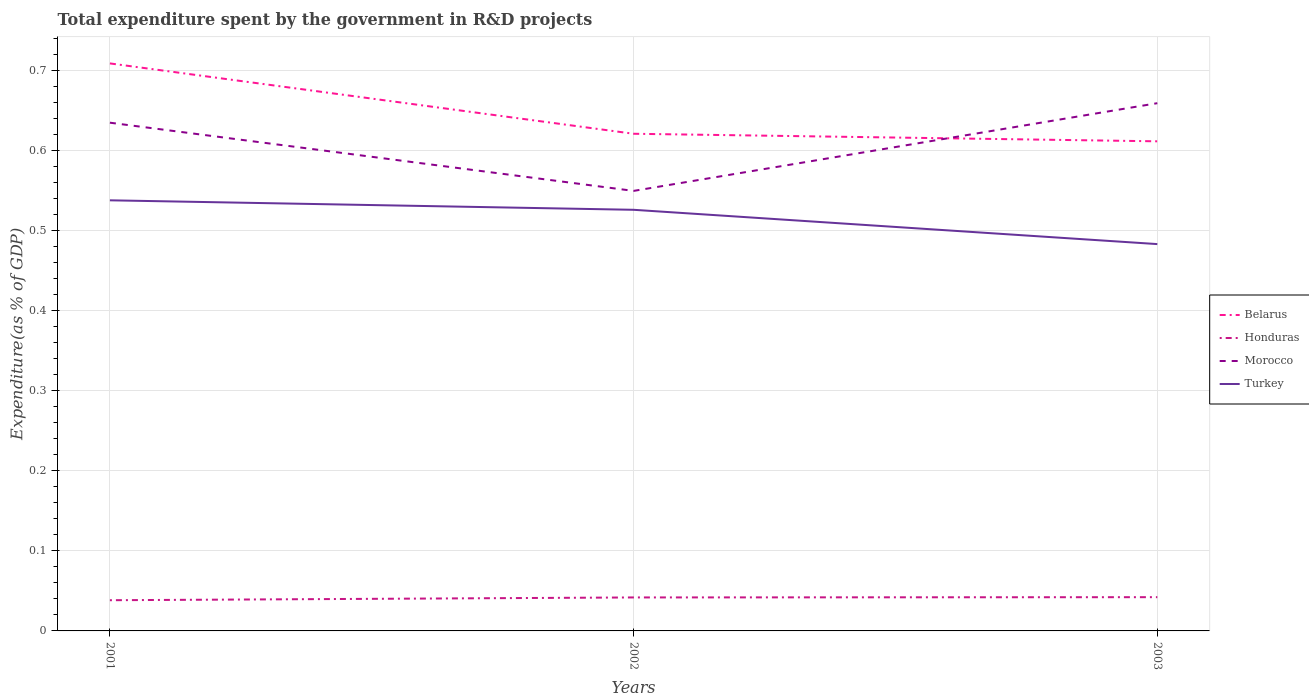How many different coloured lines are there?
Keep it short and to the point. 4. Across all years, what is the maximum total expenditure spent by the government in R&D projects in Morocco?
Keep it short and to the point. 0.55. In which year was the total expenditure spent by the government in R&D projects in Turkey maximum?
Make the answer very short. 2003. What is the total total expenditure spent by the government in R&D projects in Morocco in the graph?
Ensure brevity in your answer.  -0.02. What is the difference between the highest and the second highest total expenditure spent by the government in R&D projects in Honduras?
Your response must be concise. 0. Is the total expenditure spent by the government in R&D projects in Morocco strictly greater than the total expenditure spent by the government in R&D projects in Honduras over the years?
Provide a succinct answer. No. How many lines are there?
Make the answer very short. 4. Where does the legend appear in the graph?
Give a very brief answer. Center right. What is the title of the graph?
Make the answer very short. Total expenditure spent by the government in R&D projects. What is the label or title of the Y-axis?
Provide a succinct answer. Expenditure(as % of GDP). What is the Expenditure(as % of GDP) in Belarus in 2001?
Your response must be concise. 0.71. What is the Expenditure(as % of GDP) of Honduras in 2001?
Give a very brief answer. 0.04. What is the Expenditure(as % of GDP) of Morocco in 2001?
Offer a very short reply. 0.63. What is the Expenditure(as % of GDP) in Turkey in 2001?
Your answer should be compact. 0.54. What is the Expenditure(as % of GDP) of Belarus in 2002?
Give a very brief answer. 0.62. What is the Expenditure(as % of GDP) in Honduras in 2002?
Provide a short and direct response. 0.04. What is the Expenditure(as % of GDP) in Morocco in 2002?
Give a very brief answer. 0.55. What is the Expenditure(as % of GDP) in Turkey in 2002?
Your answer should be very brief. 0.53. What is the Expenditure(as % of GDP) of Belarus in 2003?
Offer a very short reply. 0.61. What is the Expenditure(as % of GDP) in Honduras in 2003?
Make the answer very short. 0.04. What is the Expenditure(as % of GDP) in Morocco in 2003?
Make the answer very short. 0.66. What is the Expenditure(as % of GDP) of Turkey in 2003?
Provide a succinct answer. 0.48. Across all years, what is the maximum Expenditure(as % of GDP) in Belarus?
Make the answer very short. 0.71. Across all years, what is the maximum Expenditure(as % of GDP) in Honduras?
Give a very brief answer. 0.04. Across all years, what is the maximum Expenditure(as % of GDP) of Morocco?
Provide a short and direct response. 0.66. Across all years, what is the maximum Expenditure(as % of GDP) of Turkey?
Offer a very short reply. 0.54. Across all years, what is the minimum Expenditure(as % of GDP) in Belarus?
Your answer should be compact. 0.61. Across all years, what is the minimum Expenditure(as % of GDP) of Honduras?
Offer a very short reply. 0.04. Across all years, what is the minimum Expenditure(as % of GDP) in Morocco?
Offer a terse response. 0.55. Across all years, what is the minimum Expenditure(as % of GDP) in Turkey?
Give a very brief answer. 0.48. What is the total Expenditure(as % of GDP) in Belarus in the graph?
Provide a succinct answer. 1.94. What is the total Expenditure(as % of GDP) in Honduras in the graph?
Your answer should be very brief. 0.12. What is the total Expenditure(as % of GDP) of Morocco in the graph?
Offer a very short reply. 1.84. What is the total Expenditure(as % of GDP) of Turkey in the graph?
Offer a very short reply. 1.55. What is the difference between the Expenditure(as % of GDP) of Belarus in 2001 and that in 2002?
Ensure brevity in your answer.  0.09. What is the difference between the Expenditure(as % of GDP) in Honduras in 2001 and that in 2002?
Your response must be concise. -0. What is the difference between the Expenditure(as % of GDP) of Morocco in 2001 and that in 2002?
Provide a short and direct response. 0.09. What is the difference between the Expenditure(as % of GDP) of Turkey in 2001 and that in 2002?
Keep it short and to the point. 0.01. What is the difference between the Expenditure(as % of GDP) in Belarus in 2001 and that in 2003?
Your answer should be very brief. 0.1. What is the difference between the Expenditure(as % of GDP) in Honduras in 2001 and that in 2003?
Your answer should be compact. -0. What is the difference between the Expenditure(as % of GDP) of Morocco in 2001 and that in 2003?
Your answer should be compact. -0.02. What is the difference between the Expenditure(as % of GDP) of Turkey in 2001 and that in 2003?
Offer a very short reply. 0.05. What is the difference between the Expenditure(as % of GDP) in Belarus in 2002 and that in 2003?
Make the answer very short. 0.01. What is the difference between the Expenditure(as % of GDP) in Honduras in 2002 and that in 2003?
Offer a terse response. -0. What is the difference between the Expenditure(as % of GDP) of Morocco in 2002 and that in 2003?
Offer a very short reply. -0.11. What is the difference between the Expenditure(as % of GDP) in Turkey in 2002 and that in 2003?
Keep it short and to the point. 0.04. What is the difference between the Expenditure(as % of GDP) in Belarus in 2001 and the Expenditure(as % of GDP) in Honduras in 2002?
Keep it short and to the point. 0.67. What is the difference between the Expenditure(as % of GDP) in Belarus in 2001 and the Expenditure(as % of GDP) in Morocco in 2002?
Your response must be concise. 0.16. What is the difference between the Expenditure(as % of GDP) of Belarus in 2001 and the Expenditure(as % of GDP) of Turkey in 2002?
Ensure brevity in your answer.  0.18. What is the difference between the Expenditure(as % of GDP) of Honduras in 2001 and the Expenditure(as % of GDP) of Morocco in 2002?
Ensure brevity in your answer.  -0.51. What is the difference between the Expenditure(as % of GDP) of Honduras in 2001 and the Expenditure(as % of GDP) of Turkey in 2002?
Your answer should be very brief. -0.49. What is the difference between the Expenditure(as % of GDP) in Morocco in 2001 and the Expenditure(as % of GDP) in Turkey in 2002?
Provide a succinct answer. 0.11. What is the difference between the Expenditure(as % of GDP) of Belarus in 2001 and the Expenditure(as % of GDP) of Honduras in 2003?
Provide a succinct answer. 0.67. What is the difference between the Expenditure(as % of GDP) of Belarus in 2001 and the Expenditure(as % of GDP) of Morocco in 2003?
Offer a very short reply. 0.05. What is the difference between the Expenditure(as % of GDP) in Belarus in 2001 and the Expenditure(as % of GDP) in Turkey in 2003?
Keep it short and to the point. 0.23. What is the difference between the Expenditure(as % of GDP) in Honduras in 2001 and the Expenditure(as % of GDP) in Morocco in 2003?
Provide a short and direct response. -0.62. What is the difference between the Expenditure(as % of GDP) of Honduras in 2001 and the Expenditure(as % of GDP) of Turkey in 2003?
Keep it short and to the point. -0.44. What is the difference between the Expenditure(as % of GDP) of Morocco in 2001 and the Expenditure(as % of GDP) of Turkey in 2003?
Your answer should be compact. 0.15. What is the difference between the Expenditure(as % of GDP) of Belarus in 2002 and the Expenditure(as % of GDP) of Honduras in 2003?
Your answer should be very brief. 0.58. What is the difference between the Expenditure(as % of GDP) of Belarus in 2002 and the Expenditure(as % of GDP) of Morocco in 2003?
Provide a short and direct response. -0.04. What is the difference between the Expenditure(as % of GDP) of Belarus in 2002 and the Expenditure(as % of GDP) of Turkey in 2003?
Your answer should be very brief. 0.14. What is the difference between the Expenditure(as % of GDP) of Honduras in 2002 and the Expenditure(as % of GDP) of Morocco in 2003?
Your answer should be compact. -0.62. What is the difference between the Expenditure(as % of GDP) in Honduras in 2002 and the Expenditure(as % of GDP) in Turkey in 2003?
Your answer should be compact. -0.44. What is the difference between the Expenditure(as % of GDP) in Morocco in 2002 and the Expenditure(as % of GDP) in Turkey in 2003?
Give a very brief answer. 0.07. What is the average Expenditure(as % of GDP) of Belarus per year?
Your answer should be very brief. 0.65. What is the average Expenditure(as % of GDP) in Honduras per year?
Your response must be concise. 0.04. What is the average Expenditure(as % of GDP) in Morocco per year?
Provide a succinct answer. 0.61. What is the average Expenditure(as % of GDP) of Turkey per year?
Offer a very short reply. 0.52. In the year 2001, what is the difference between the Expenditure(as % of GDP) of Belarus and Expenditure(as % of GDP) of Honduras?
Your answer should be very brief. 0.67. In the year 2001, what is the difference between the Expenditure(as % of GDP) of Belarus and Expenditure(as % of GDP) of Morocco?
Your answer should be compact. 0.07. In the year 2001, what is the difference between the Expenditure(as % of GDP) of Belarus and Expenditure(as % of GDP) of Turkey?
Keep it short and to the point. 0.17. In the year 2001, what is the difference between the Expenditure(as % of GDP) in Honduras and Expenditure(as % of GDP) in Morocco?
Provide a succinct answer. -0.6. In the year 2001, what is the difference between the Expenditure(as % of GDP) of Honduras and Expenditure(as % of GDP) of Turkey?
Provide a succinct answer. -0.5. In the year 2001, what is the difference between the Expenditure(as % of GDP) in Morocco and Expenditure(as % of GDP) in Turkey?
Provide a succinct answer. 0.1. In the year 2002, what is the difference between the Expenditure(as % of GDP) in Belarus and Expenditure(as % of GDP) in Honduras?
Give a very brief answer. 0.58. In the year 2002, what is the difference between the Expenditure(as % of GDP) of Belarus and Expenditure(as % of GDP) of Morocco?
Offer a terse response. 0.07. In the year 2002, what is the difference between the Expenditure(as % of GDP) in Belarus and Expenditure(as % of GDP) in Turkey?
Your answer should be compact. 0.1. In the year 2002, what is the difference between the Expenditure(as % of GDP) of Honduras and Expenditure(as % of GDP) of Morocco?
Offer a very short reply. -0.51. In the year 2002, what is the difference between the Expenditure(as % of GDP) in Honduras and Expenditure(as % of GDP) in Turkey?
Give a very brief answer. -0.48. In the year 2002, what is the difference between the Expenditure(as % of GDP) in Morocco and Expenditure(as % of GDP) in Turkey?
Keep it short and to the point. 0.02. In the year 2003, what is the difference between the Expenditure(as % of GDP) in Belarus and Expenditure(as % of GDP) in Honduras?
Make the answer very short. 0.57. In the year 2003, what is the difference between the Expenditure(as % of GDP) of Belarus and Expenditure(as % of GDP) of Morocco?
Make the answer very short. -0.05. In the year 2003, what is the difference between the Expenditure(as % of GDP) in Belarus and Expenditure(as % of GDP) in Turkey?
Your answer should be very brief. 0.13. In the year 2003, what is the difference between the Expenditure(as % of GDP) of Honduras and Expenditure(as % of GDP) of Morocco?
Your answer should be compact. -0.62. In the year 2003, what is the difference between the Expenditure(as % of GDP) in Honduras and Expenditure(as % of GDP) in Turkey?
Offer a very short reply. -0.44. In the year 2003, what is the difference between the Expenditure(as % of GDP) of Morocco and Expenditure(as % of GDP) of Turkey?
Keep it short and to the point. 0.18. What is the ratio of the Expenditure(as % of GDP) in Belarus in 2001 to that in 2002?
Your response must be concise. 1.14. What is the ratio of the Expenditure(as % of GDP) of Honduras in 2001 to that in 2002?
Give a very brief answer. 0.92. What is the ratio of the Expenditure(as % of GDP) in Morocco in 2001 to that in 2002?
Make the answer very short. 1.16. What is the ratio of the Expenditure(as % of GDP) of Turkey in 2001 to that in 2002?
Your answer should be very brief. 1.02. What is the ratio of the Expenditure(as % of GDP) in Belarus in 2001 to that in 2003?
Provide a succinct answer. 1.16. What is the ratio of the Expenditure(as % of GDP) in Honduras in 2001 to that in 2003?
Your response must be concise. 0.91. What is the ratio of the Expenditure(as % of GDP) in Turkey in 2001 to that in 2003?
Provide a succinct answer. 1.11. What is the ratio of the Expenditure(as % of GDP) of Belarus in 2002 to that in 2003?
Ensure brevity in your answer.  1.02. What is the ratio of the Expenditure(as % of GDP) of Morocco in 2002 to that in 2003?
Offer a terse response. 0.83. What is the ratio of the Expenditure(as % of GDP) of Turkey in 2002 to that in 2003?
Provide a succinct answer. 1.09. What is the difference between the highest and the second highest Expenditure(as % of GDP) in Belarus?
Your response must be concise. 0.09. What is the difference between the highest and the second highest Expenditure(as % of GDP) of Morocco?
Make the answer very short. 0.02. What is the difference between the highest and the second highest Expenditure(as % of GDP) in Turkey?
Give a very brief answer. 0.01. What is the difference between the highest and the lowest Expenditure(as % of GDP) in Belarus?
Your response must be concise. 0.1. What is the difference between the highest and the lowest Expenditure(as % of GDP) of Honduras?
Give a very brief answer. 0. What is the difference between the highest and the lowest Expenditure(as % of GDP) in Morocco?
Your response must be concise. 0.11. What is the difference between the highest and the lowest Expenditure(as % of GDP) in Turkey?
Your answer should be very brief. 0.05. 